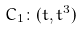<formula> <loc_0><loc_0><loc_500><loc_500>C _ { 1 } \colon ( t , t ^ { 3 } )</formula> 